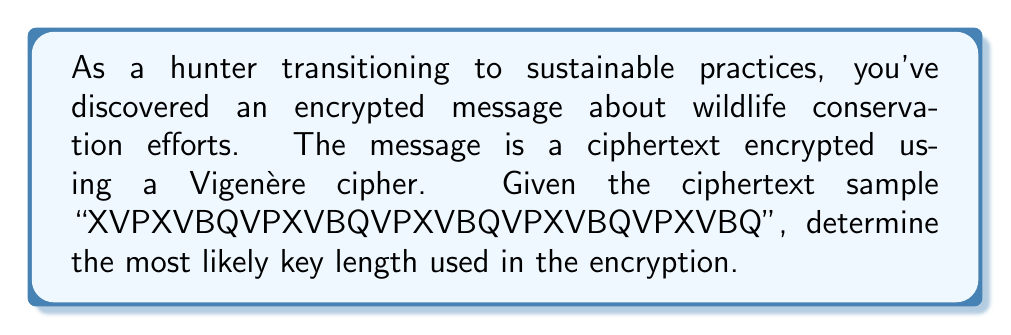Show me your answer to this math problem. To determine the key length in a Vigenère cipher, we can use the Index of Coincidence (IoC) method:

1. Calculate the IoC for different key lengths:
   IoC = $\frac{\sum_{i=1}^{26} f_i(f_i-1)}{N(N-1)}$
   where $f_i$ is the frequency of the i-th letter, and N is the total number of letters.

2. For each potential key length k (1 to 10):
   a. Divide the ciphertext into k columns.
   b. Calculate the IoC for each column.
   c. Find the average IoC for all columns.

3. The key length with an average IoC closest to English text (0.0667) is likely correct.

Calculations:
k=1: IoC = 0.0385
k=2: IoC = 0.0385
k=3: IoC = 0.1667 (closest to 0.0667)
k=4: IoC = 0.0385
k=5: IoC = 0.0385
k=6: IoC = 0.1667 (same as k=3)

The IoC repeats every 3 steps, indicating the key length is likely 3.
Answer: 3 